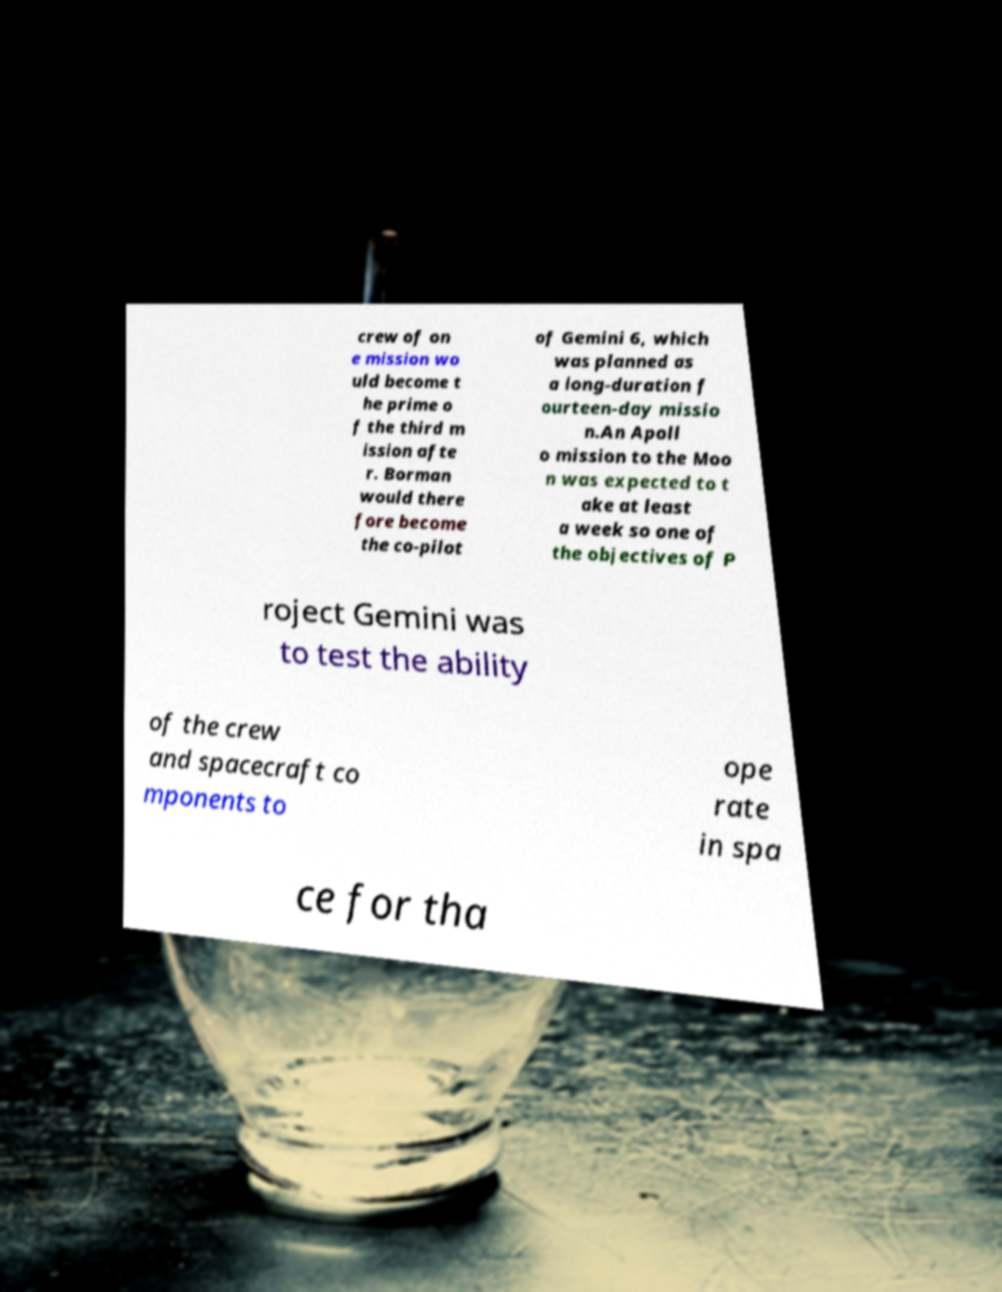Could you extract and type out the text from this image? crew of on e mission wo uld become t he prime o f the third m ission afte r. Borman would there fore become the co-pilot of Gemini 6, which was planned as a long-duration f ourteen-day missio n.An Apoll o mission to the Moo n was expected to t ake at least a week so one of the objectives of P roject Gemini was to test the ability of the crew and spacecraft co mponents to ope rate in spa ce for tha 